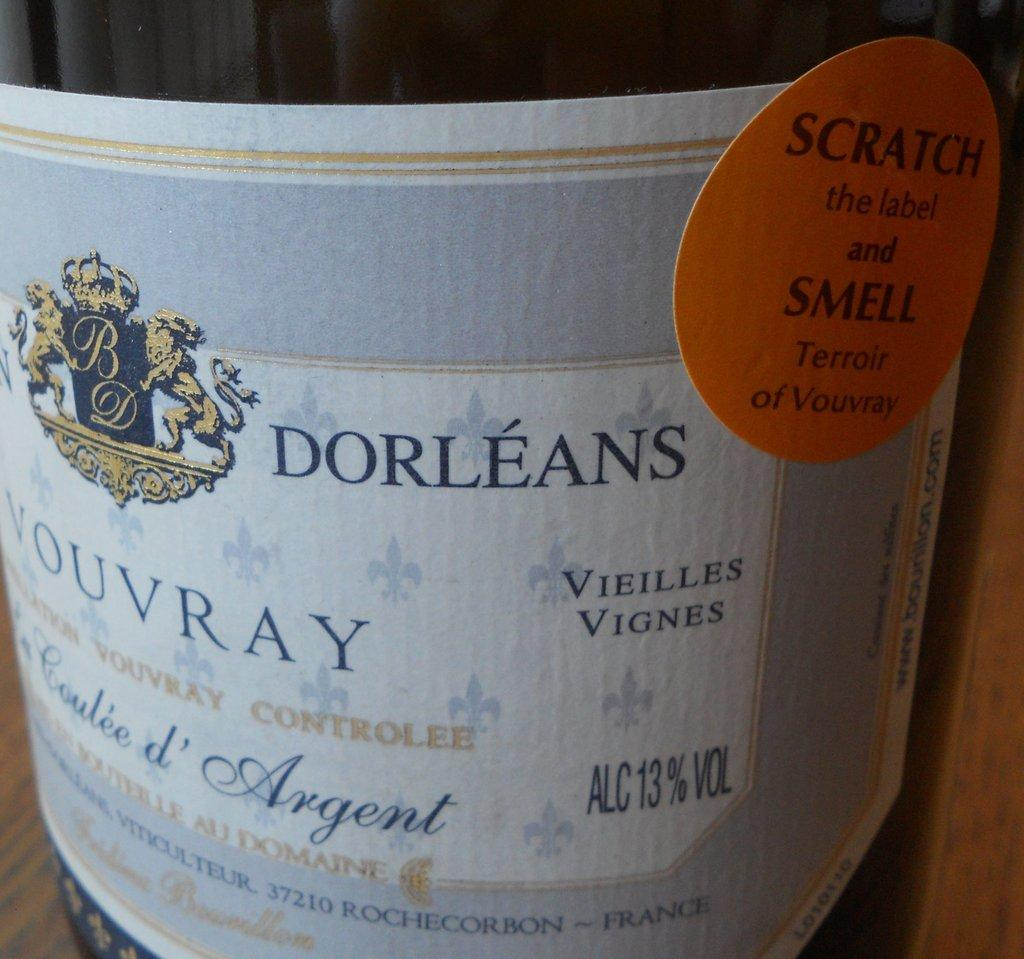<image>
Relay a brief, clear account of the picture shown. The label of a bottle of wine with Dorleans on it. 